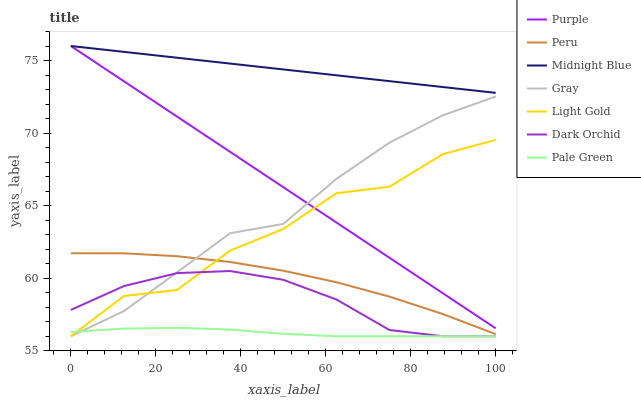Does Pale Green have the minimum area under the curve?
Answer yes or no. Yes. Does Midnight Blue have the maximum area under the curve?
Answer yes or no. Yes. Does Purple have the minimum area under the curve?
Answer yes or no. No. Does Purple have the maximum area under the curve?
Answer yes or no. No. Is Purple the smoothest?
Answer yes or no. Yes. Is Light Gold the roughest?
Answer yes or no. Yes. Is Midnight Blue the smoothest?
Answer yes or no. No. Is Midnight Blue the roughest?
Answer yes or no. No. Does Gray have the lowest value?
Answer yes or no. Yes. Does Purple have the lowest value?
Answer yes or no. No. Does Purple have the highest value?
Answer yes or no. Yes. Does Dark Orchid have the highest value?
Answer yes or no. No. Is Dark Orchid less than Midnight Blue?
Answer yes or no. Yes. Is Midnight Blue greater than Peru?
Answer yes or no. Yes. Does Light Gold intersect Pale Green?
Answer yes or no. Yes. Is Light Gold less than Pale Green?
Answer yes or no. No. Is Light Gold greater than Pale Green?
Answer yes or no. No. Does Dark Orchid intersect Midnight Blue?
Answer yes or no. No. 